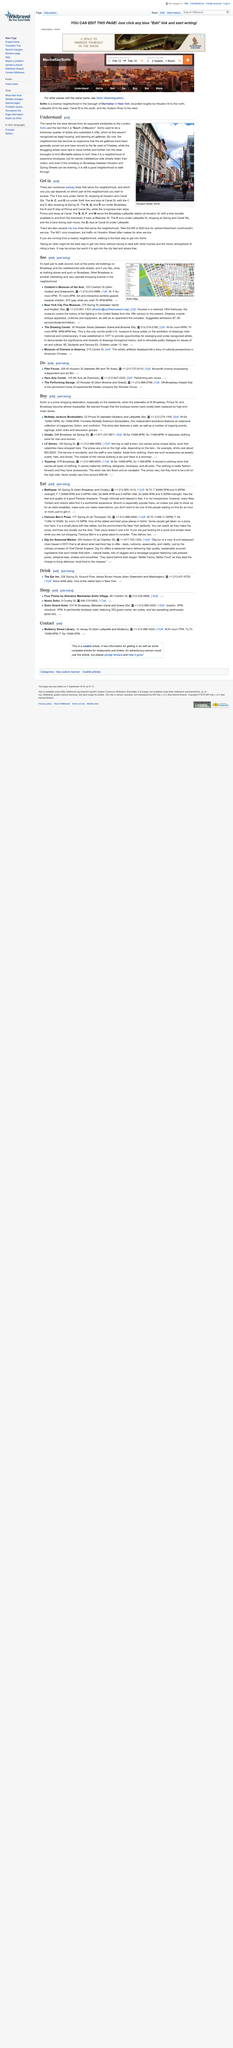List a handful of essential elements in this visual. SoHo is a neighborhood located within a city. Therefore, it can be declared that SoHo is part of a city. There are fewer art galleries in SoHo now than there used to be, and this is because the high rents in the area have caused many galleries to relocate. Yes, there are narrow cobblestone side streets in SoHo that add to its historic charm. 